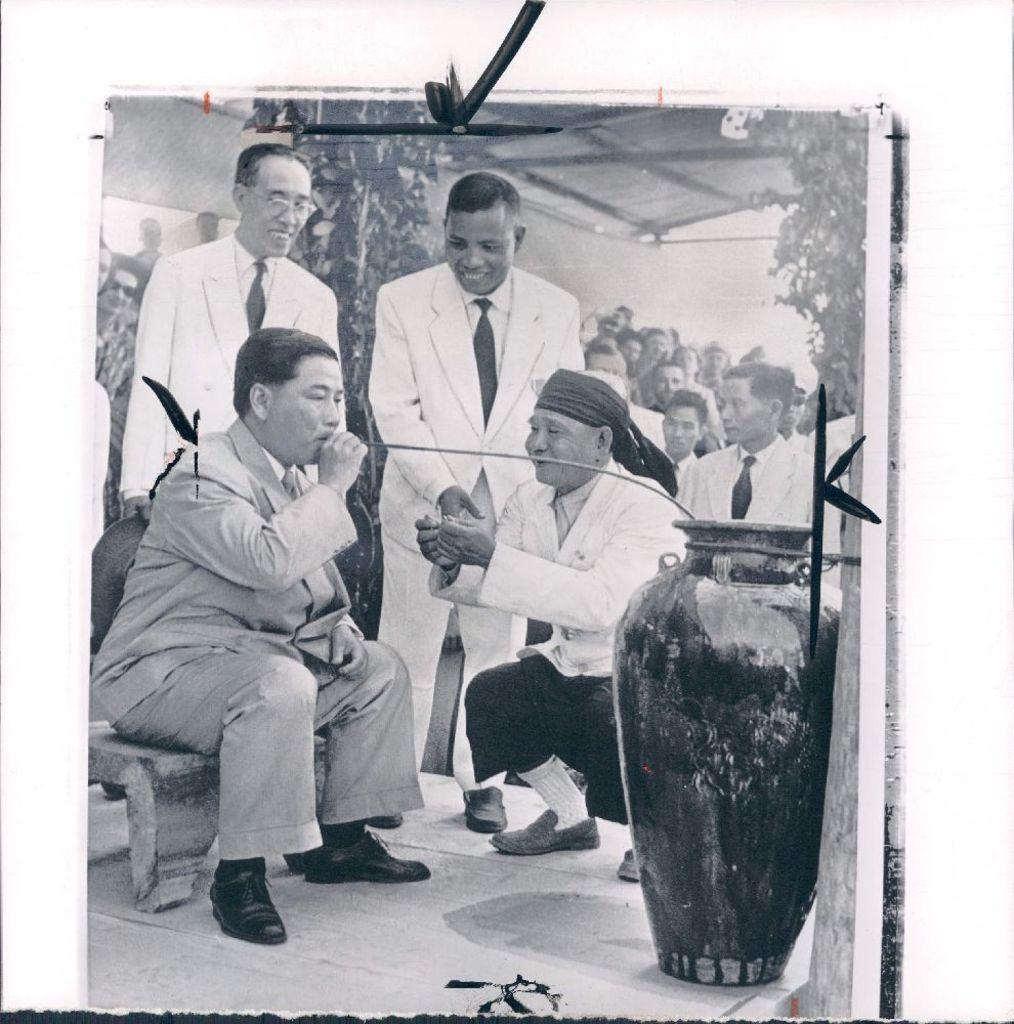Describe this image in one or two sentences. This is a black and white edited image, where we can see the pot on the right side and a men sitting on the stool and holding straw in his hand on the left side. In the background, there are three men standing and squatting around the person. We can also see the crowd, shed and the plants in the background. 